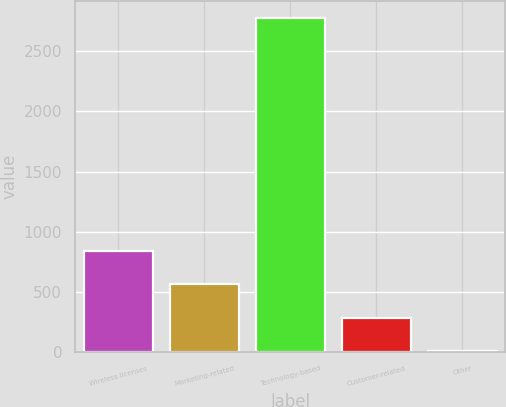<chart> <loc_0><loc_0><loc_500><loc_500><bar_chart><fcel>Wireless licenses<fcel>Marketing-related<fcel>Technology-based<fcel>Customer-related<fcel>Other<nl><fcel>839.7<fcel>562.8<fcel>2778<fcel>285.9<fcel>9<nl></chart> 